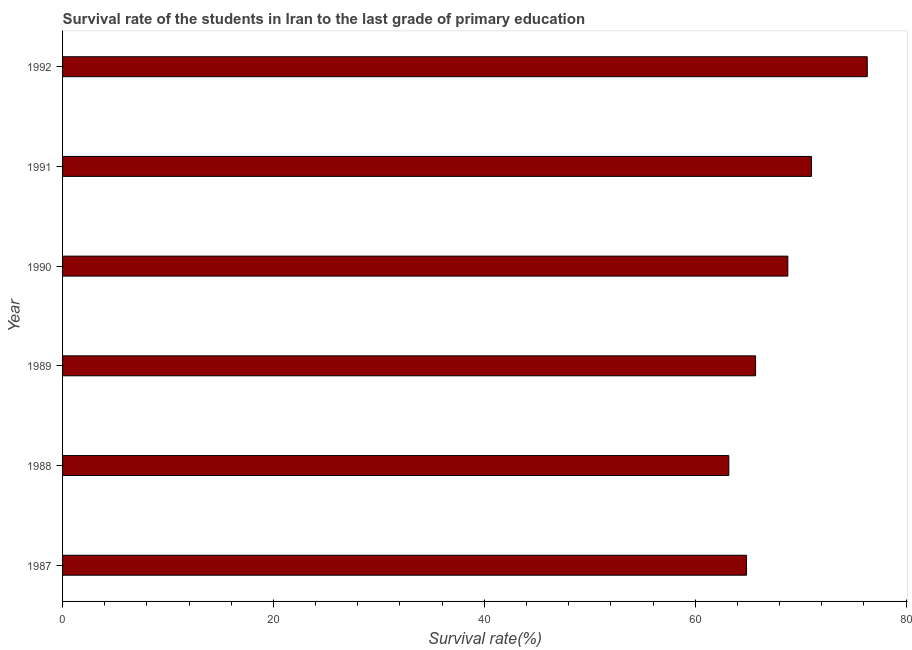Does the graph contain any zero values?
Give a very brief answer. No. Does the graph contain grids?
Your answer should be compact. No. What is the title of the graph?
Offer a terse response. Survival rate of the students in Iran to the last grade of primary education. What is the label or title of the X-axis?
Make the answer very short. Survival rate(%). What is the label or title of the Y-axis?
Make the answer very short. Year. What is the survival rate in primary education in 1988?
Provide a short and direct response. 63.18. Across all years, what is the maximum survival rate in primary education?
Make the answer very short. 76.31. Across all years, what is the minimum survival rate in primary education?
Provide a short and direct response. 63.18. In which year was the survival rate in primary education minimum?
Ensure brevity in your answer.  1988. What is the sum of the survival rate in primary education?
Your response must be concise. 409.89. What is the difference between the survival rate in primary education in 1988 and 1991?
Offer a very short reply. -7.84. What is the average survival rate in primary education per year?
Your answer should be very brief. 68.31. What is the median survival rate in primary education?
Provide a succinct answer. 67.25. Do a majority of the years between 1987 and 1988 (inclusive) have survival rate in primary education greater than 52 %?
Ensure brevity in your answer.  Yes. Is the survival rate in primary education in 1988 less than that in 1992?
Your response must be concise. Yes. Is the difference between the survival rate in primary education in 1989 and 1991 greater than the difference between any two years?
Give a very brief answer. No. What is the difference between the highest and the second highest survival rate in primary education?
Provide a succinct answer. 5.29. What is the difference between the highest and the lowest survival rate in primary education?
Provide a succinct answer. 13.13. In how many years, is the survival rate in primary education greater than the average survival rate in primary education taken over all years?
Keep it short and to the point. 3. How many bars are there?
Your answer should be very brief. 6. Are all the bars in the graph horizontal?
Your answer should be very brief. Yes. How many years are there in the graph?
Ensure brevity in your answer.  6. What is the difference between two consecutive major ticks on the X-axis?
Your answer should be compact. 20. Are the values on the major ticks of X-axis written in scientific E-notation?
Offer a very short reply. No. What is the Survival rate(%) in 1987?
Your answer should be very brief. 64.87. What is the Survival rate(%) of 1988?
Make the answer very short. 63.18. What is the Survival rate(%) of 1989?
Provide a succinct answer. 65.72. What is the Survival rate(%) in 1990?
Give a very brief answer. 68.78. What is the Survival rate(%) in 1991?
Offer a terse response. 71.02. What is the Survival rate(%) of 1992?
Offer a terse response. 76.31. What is the difference between the Survival rate(%) in 1987 and 1988?
Make the answer very short. 1.68. What is the difference between the Survival rate(%) in 1987 and 1989?
Ensure brevity in your answer.  -0.86. What is the difference between the Survival rate(%) in 1987 and 1990?
Offer a terse response. -3.92. What is the difference between the Survival rate(%) in 1987 and 1991?
Offer a very short reply. -6.16. What is the difference between the Survival rate(%) in 1987 and 1992?
Your answer should be very brief. -11.45. What is the difference between the Survival rate(%) in 1988 and 1989?
Ensure brevity in your answer.  -2.54. What is the difference between the Survival rate(%) in 1988 and 1990?
Keep it short and to the point. -5.6. What is the difference between the Survival rate(%) in 1988 and 1991?
Offer a terse response. -7.84. What is the difference between the Survival rate(%) in 1988 and 1992?
Provide a short and direct response. -13.13. What is the difference between the Survival rate(%) in 1989 and 1990?
Make the answer very short. -3.06. What is the difference between the Survival rate(%) in 1989 and 1991?
Make the answer very short. -5.3. What is the difference between the Survival rate(%) in 1989 and 1992?
Your response must be concise. -10.59. What is the difference between the Survival rate(%) in 1990 and 1991?
Your answer should be very brief. -2.24. What is the difference between the Survival rate(%) in 1990 and 1992?
Provide a succinct answer. -7.53. What is the difference between the Survival rate(%) in 1991 and 1992?
Your response must be concise. -5.29. What is the ratio of the Survival rate(%) in 1987 to that in 1988?
Provide a short and direct response. 1.03. What is the ratio of the Survival rate(%) in 1987 to that in 1989?
Offer a very short reply. 0.99. What is the ratio of the Survival rate(%) in 1987 to that in 1990?
Provide a short and direct response. 0.94. What is the ratio of the Survival rate(%) in 1987 to that in 1991?
Offer a terse response. 0.91. What is the ratio of the Survival rate(%) in 1988 to that in 1990?
Offer a terse response. 0.92. What is the ratio of the Survival rate(%) in 1988 to that in 1991?
Make the answer very short. 0.89. What is the ratio of the Survival rate(%) in 1988 to that in 1992?
Ensure brevity in your answer.  0.83. What is the ratio of the Survival rate(%) in 1989 to that in 1990?
Ensure brevity in your answer.  0.96. What is the ratio of the Survival rate(%) in 1989 to that in 1991?
Keep it short and to the point. 0.93. What is the ratio of the Survival rate(%) in 1989 to that in 1992?
Your answer should be very brief. 0.86. What is the ratio of the Survival rate(%) in 1990 to that in 1991?
Ensure brevity in your answer.  0.97. What is the ratio of the Survival rate(%) in 1990 to that in 1992?
Your answer should be compact. 0.9. What is the ratio of the Survival rate(%) in 1991 to that in 1992?
Your answer should be very brief. 0.93. 